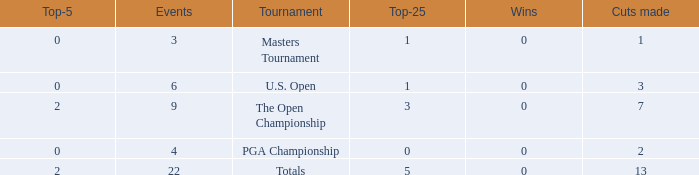What is the fewest wins for Thomas in events he had entered exactly 9 times? 0.0. 